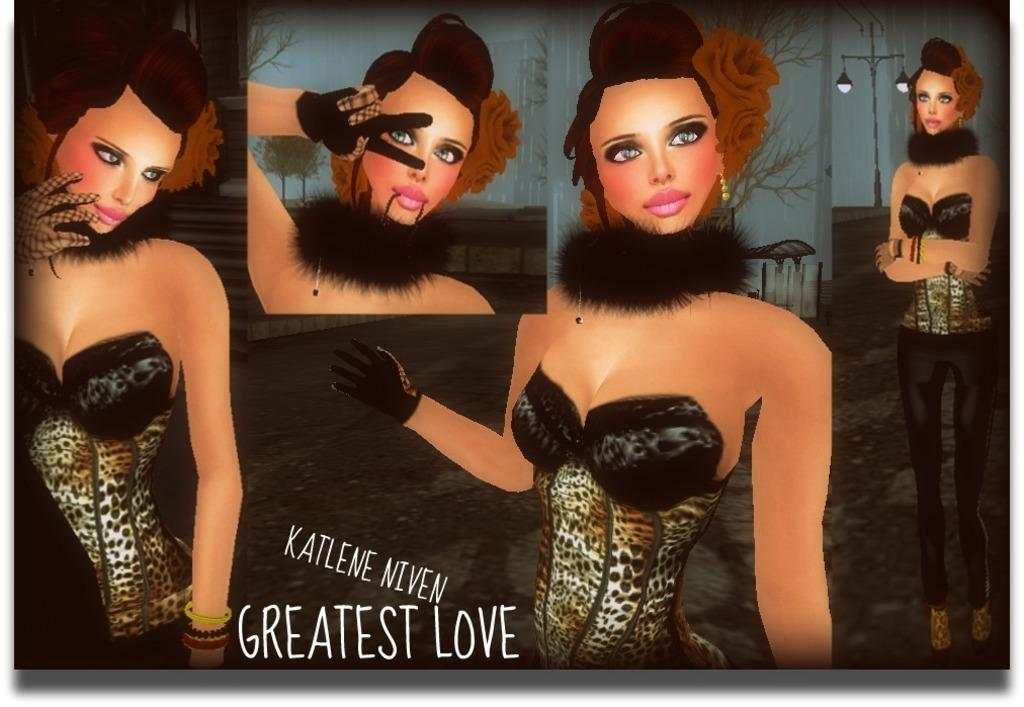What type of image is being described? The image is a drawing. What is the subject of the drawing? The drawing depicts different gestures of a lady. Are there any words or phrases included in the drawing? Yes, the phrase "the greatest love" is written in the drawing. Can you see a kitten playing with a cup in the drawing? No, there is no kitten or cup present in the drawing; it depicts a lady making different gestures and includes the phrase "the greatest love." 